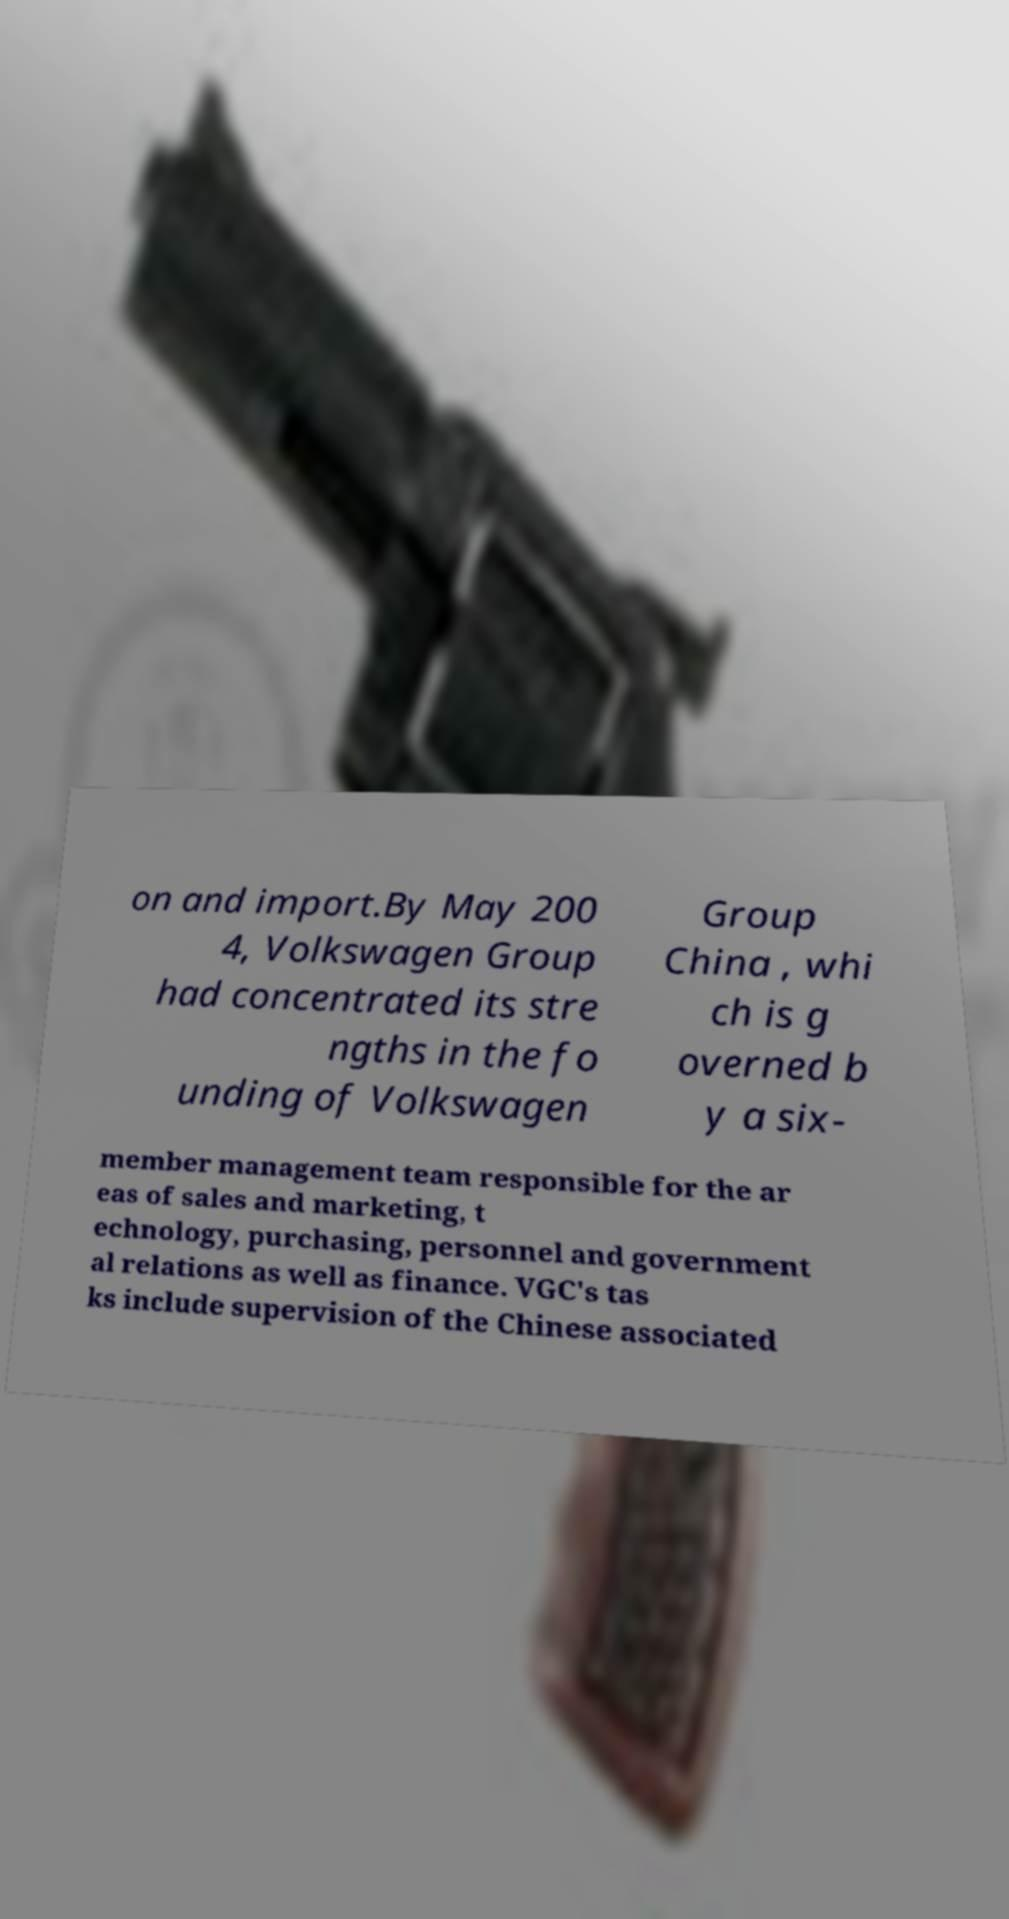I need the written content from this picture converted into text. Can you do that? on and import.By May 200 4, Volkswagen Group had concentrated its stre ngths in the fo unding of Volkswagen Group China , whi ch is g overned b y a six- member management team responsible for the ar eas of sales and marketing, t echnology, purchasing, personnel and government al relations as well as finance. VGC's tas ks include supervision of the Chinese associated 